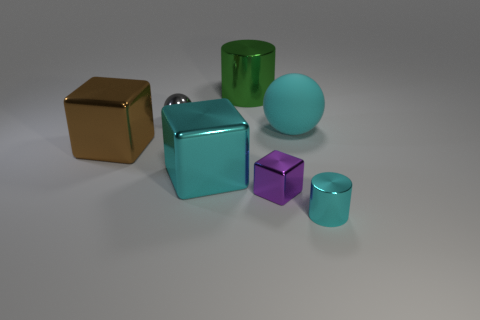Subtract all cyan cubes. How many cubes are left? 2 Subtract all purple cubes. How many cubes are left? 2 Subtract all cubes. How many objects are left? 4 Subtract 1 balls. How many balls are left? 1 Add 3 small gray cylinders. How many objects exist? 10 Subtract 0 purple cylinders. How many objects are left? 7 Subtract all purple balls. Subtract all red cylinders. How many balls are left? 2 Subtract all cyan spheres. How many cyan cubes are left? 1 Subtract all large blue things. Subtract all gray metal spheres. How many objects are left? 6 Add 5 small cyan cylinders. How many small cyan cylinders are left? 6 